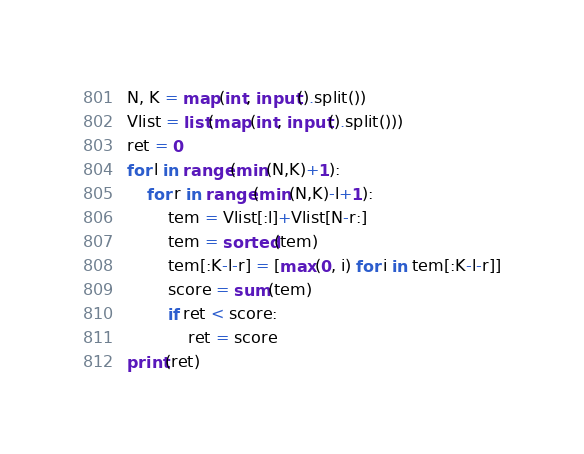<code> <loc_0><loc_0><loc_500><loc_500><_Python_>N, K = map(int, input().split())
Vlist = list(map(int, input().split()))
ret = 0
for l in range(min(N,K)+1):
    for r in range(min(N,K)-l+1):
        tem = Vlist[:l]+Vlist[N-r:]
        tem = sorted(tem)
        tem[:K-l-r] = [max(0, i) for i in tem[:K-l-r]]
        score = sum(tem)
        if ret < score:
            ret = score
print(ret)</code> 